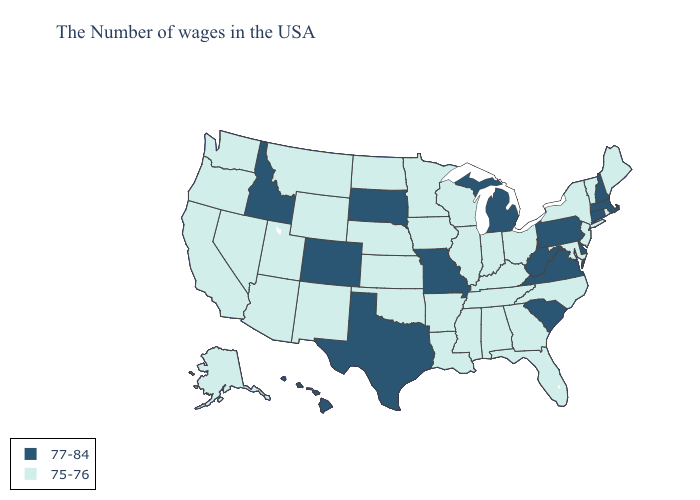Name the states that have a value in the range 75-76?
Keep it brief. Maine, Rhode Island, Vermont, New York, New Jersey, Maryland, North Carolina, Ohio, Florida, Georgia, Kentucky, Indiana, Alabama, Tennessee, Wisconsin, Illinois, Mississippi, Louisiana, Arkansas, Minnesota, Iowa, Kansas, Nebraska, Oklahoma, North Dakota, Wyoming, New Mexico, Utah, Montana, Arizona, Nevada, California, Washington, Oregon, Alaska. What is the value of Idaho?
Be succinct. 77-84. What is the highest value in states that border Wyoming?
Short answer required. 77-84. Does Idaho have the lowest value in the West?
Quick response, please. No. Does Arizona have a higher value than Texas?
Be succinct. No. Among the states that border New Jersey , does Pennsylvania have the highest value?
Answer briefly. Yes. What is the value of Oregon?
Quick response, please. 75-76. Among the states that border Connecticut , does New York have the lowest value?
Short answer required. Yes. Does Utah have the same value as Oregon?
Keep it brief. Yes. Name the states that have a value in the range 77-84?
Concise answer only. Massachusetts, New Hampshire, Connecticut, Delaware, Pennsylvania, Virginia, South Carolina, West Virginia, Michigan, Missouri, Texas, South Dakota, Colorado, Idaho, Hawaii. Name the states that have a value in the range 77-84?
Concise answer only. Massachusetts, New Hampshire, Connecticut, Delaware, Pennsylvania, Virginia, South Carolina, West Virginia, Michigan, Missouri, Texas, South Dakota, Colorado, Idaho, Hawaii. Does New Hampshire have the same value as Massachusetts?
Quick response, please. Yes. Does Georgia have the lowest value in the USA?
Concise answer only. Yes. What is the value of Montana?
Concise answer only. 75-76. Name the states that have a value in the range 77-84?
Give a very brief answer. Massachusetts, New Hampshire, Connecticut, Delaware, Pennsylvania, Virginia, South Carolina, West Virginia, Michigan, Missouri, Texas, South Dakota, Colorado, Idaho, Hawaii. 